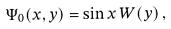<formula> <loc_0><loc_0><loc_500><loc_500>\Psi _ { 0 } ( x , y ) = \sin x \, W ( y ) \, ,</formula> 